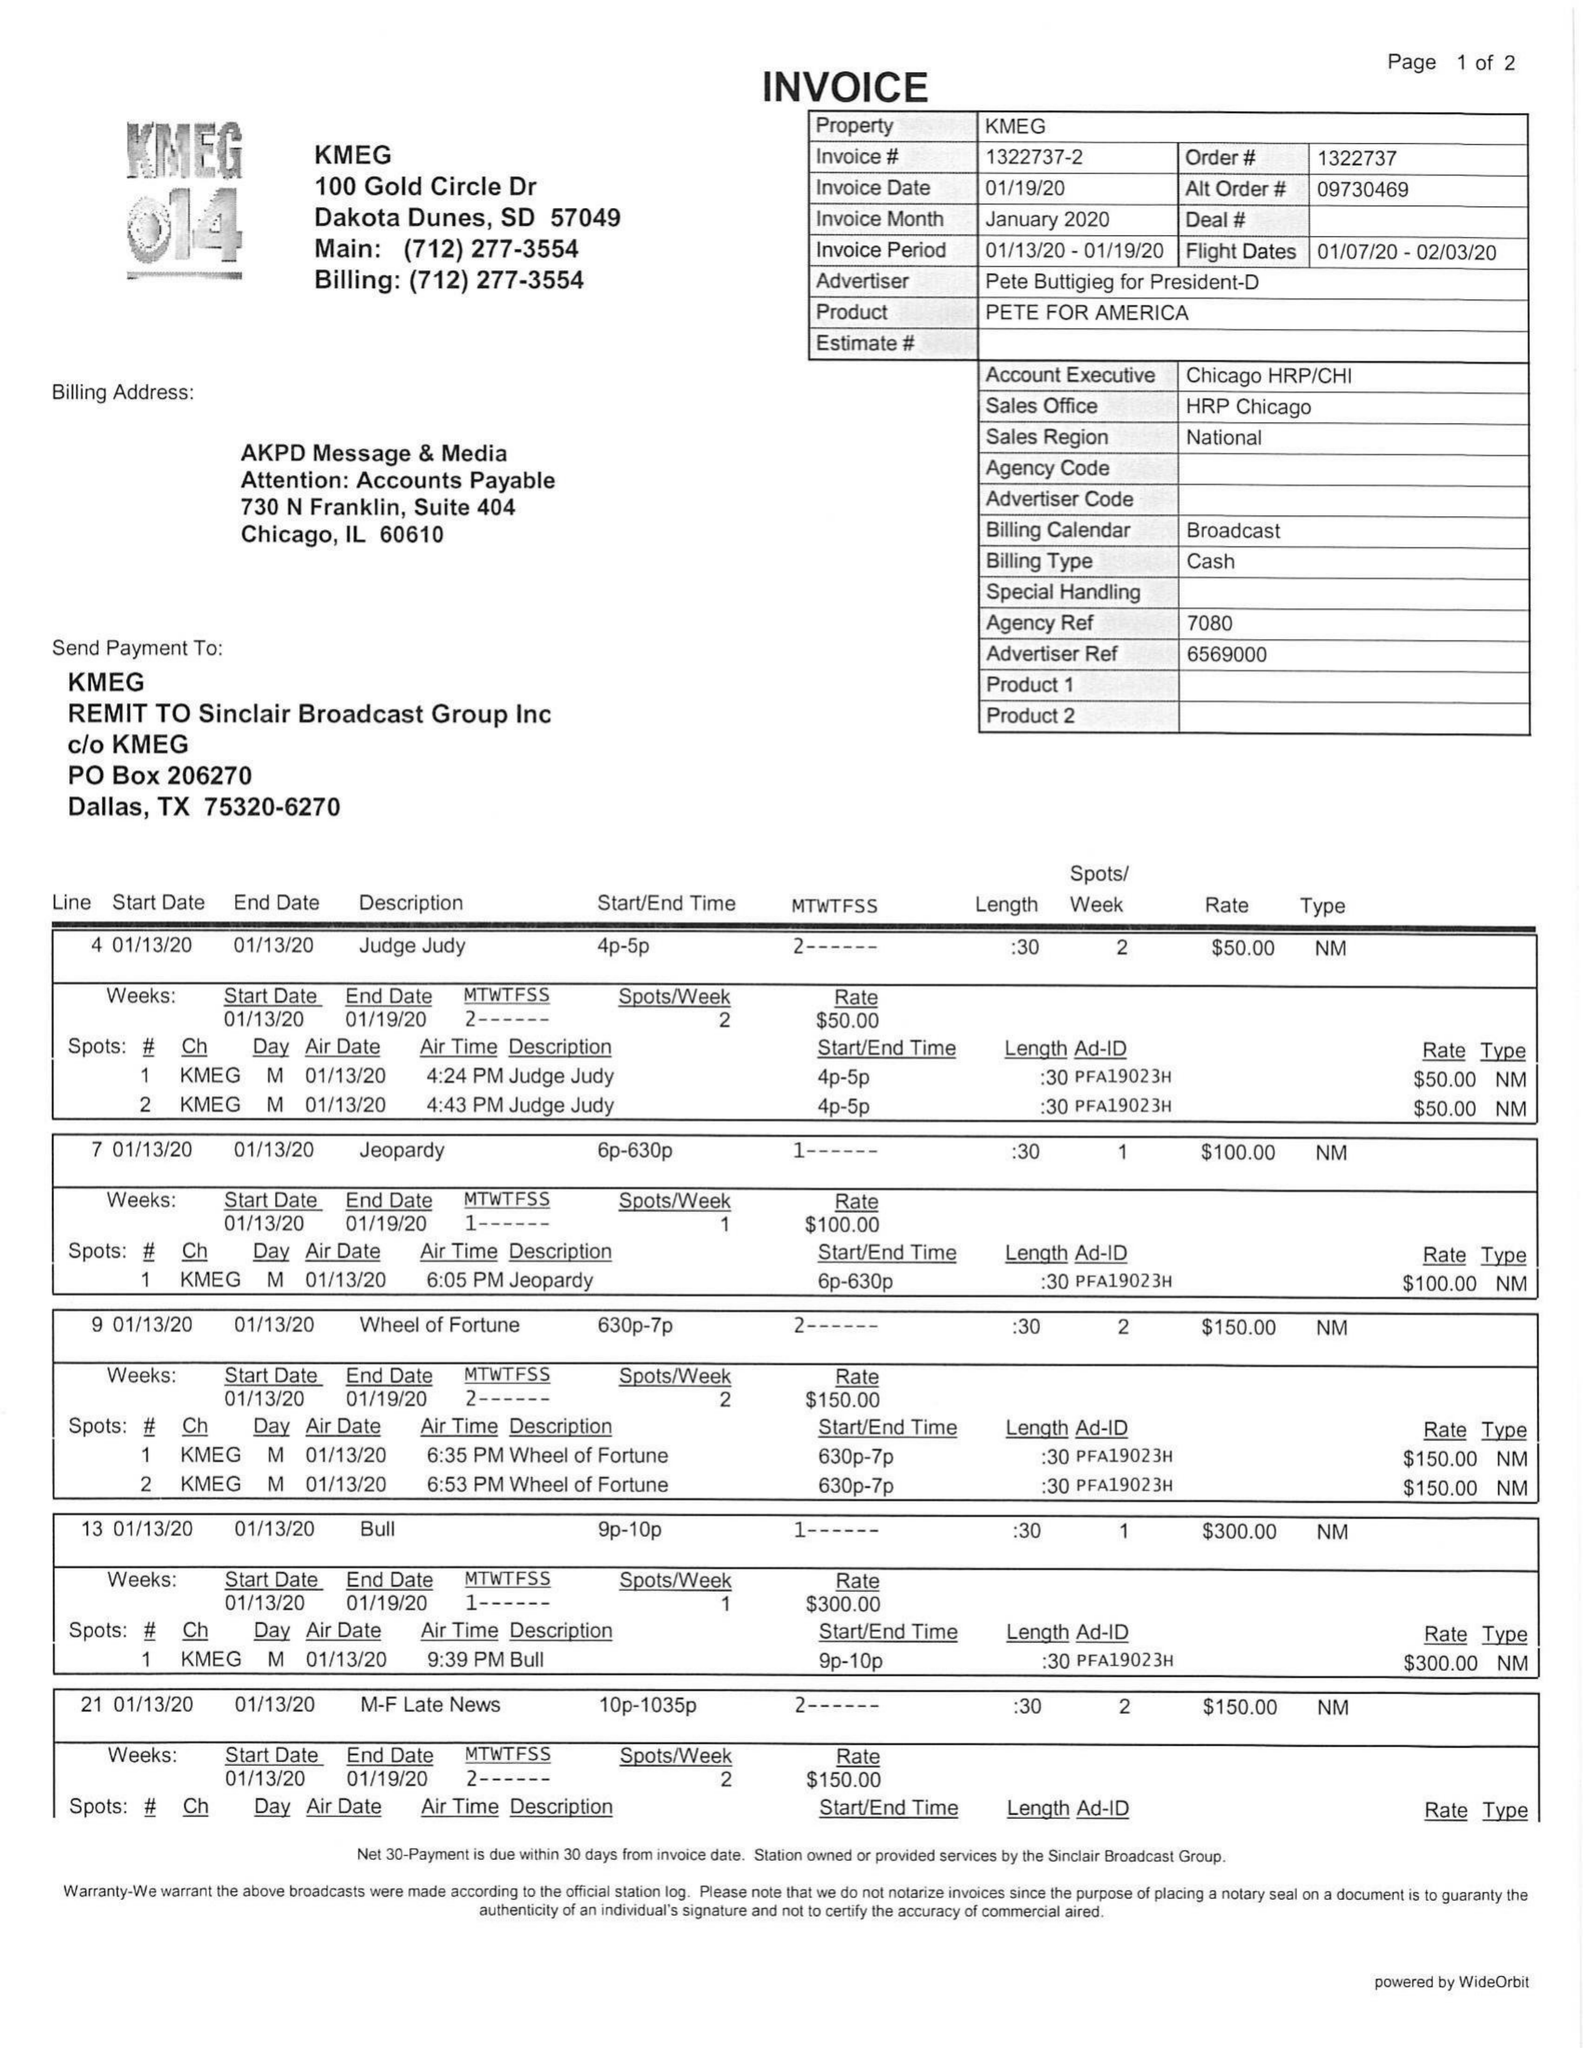What is the value for the contract_num?
Answer the question using a single word or phrase. 1322737 